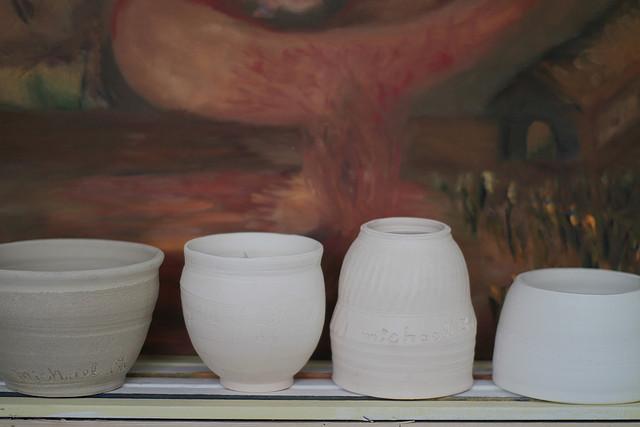Do they all have wide bases?
Short answer required. No. How many white dishes are in this scene?
Give a very brief answer. 4. Are all the vases' bases circular?
Be succinct. Yes. 